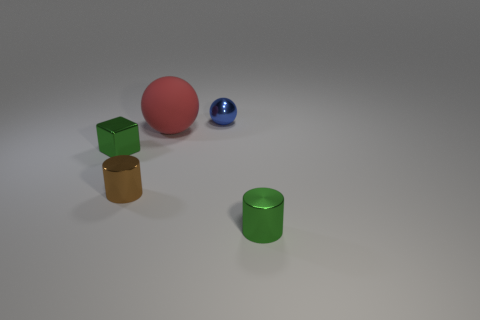Is there anything else that is made of the same material as the red thing?
Make the answer very short. No. Is there any other thing that is the same size as the matte thing?
Your answer should be very brief. No. What is the shape of the thing that is in front of the big matte thing and to the right of the tiny brown cylinder?
Your answer should be very brief. Cylinder. What number of large spheres are the same color as the cube?
Your answer should be compact. 0. Is there a small green object that is right of the metallic cylinder behind the cylinder to the right of the large red rubber sphere?
Give a very brief answer. Yes. What size is the thing that is behind the tiny metallic block and left of the tiny blue metal thing?
Offer a very short reply. Large. What number of brown objects have the same material as the large red thing?
Your answer should be compact. 0. How many cylinders are either tiny metallic things or blue shiny things?
Give a very brief answer. 2. There is a rubber object behind the metallic cylinder in front of the metallic cylinder that is left of the blue thing; what is its size?
Provide a succinct answer. Large. The tiny metallic object that is behind the brown cylinder and right of the small green cube is what color?
Keep it short and to the point. Blue. 